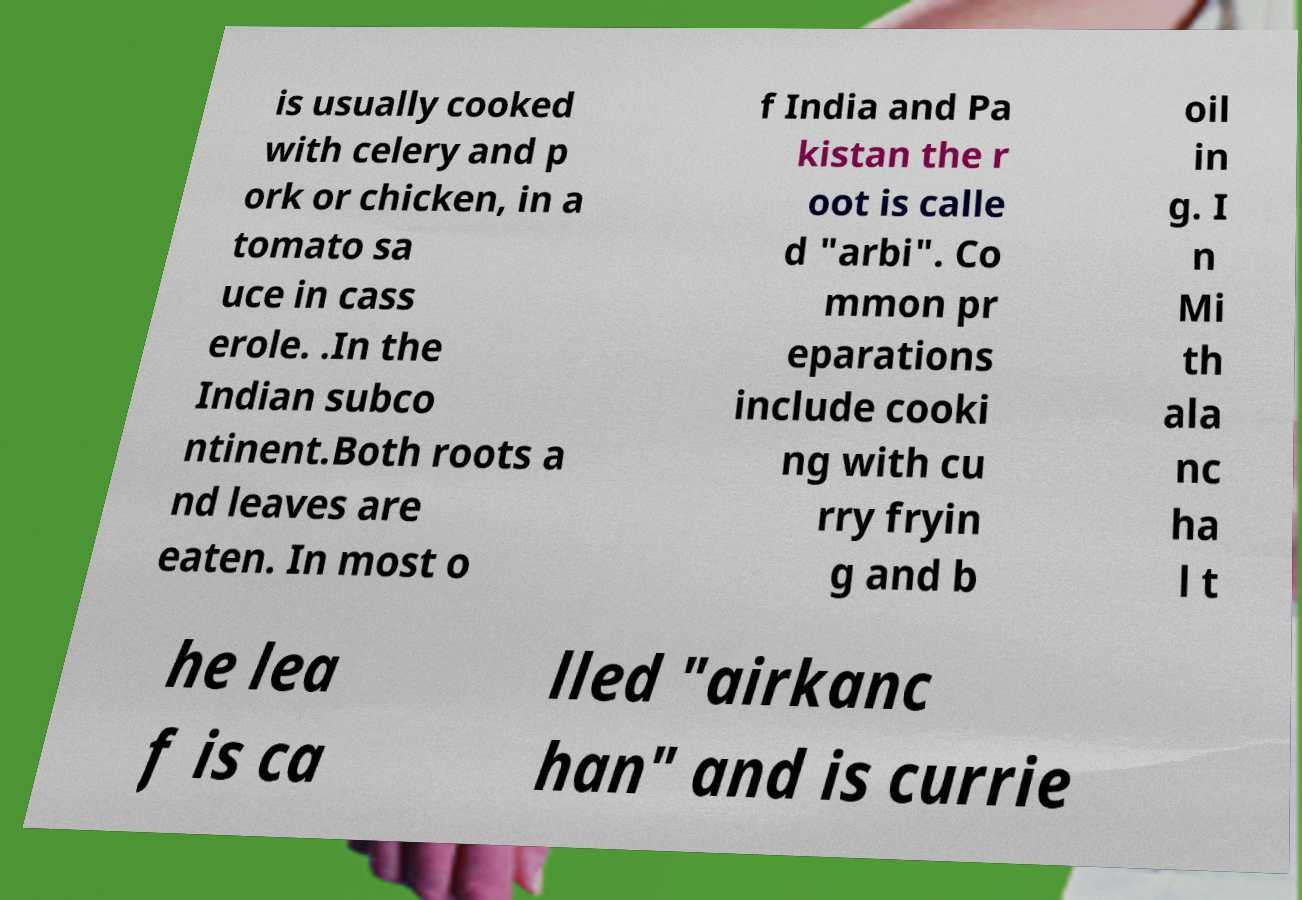I need the written content from this picture converted into text. Can you do that? is usually cooked with celery and p ork or chicken, in a tomato sa uce in cass erole. .In the Indian subco ntinent.Both roots a nd leaves are eaten. In most o f India and Pa kistan the r oot is calle d "arbi". Co mmon pr eparations include cooki ng with cu rry fryin g and b oil in g. I n Mi th ala nc ha l t he lea f is ca lled "airkanc han" and is currie 